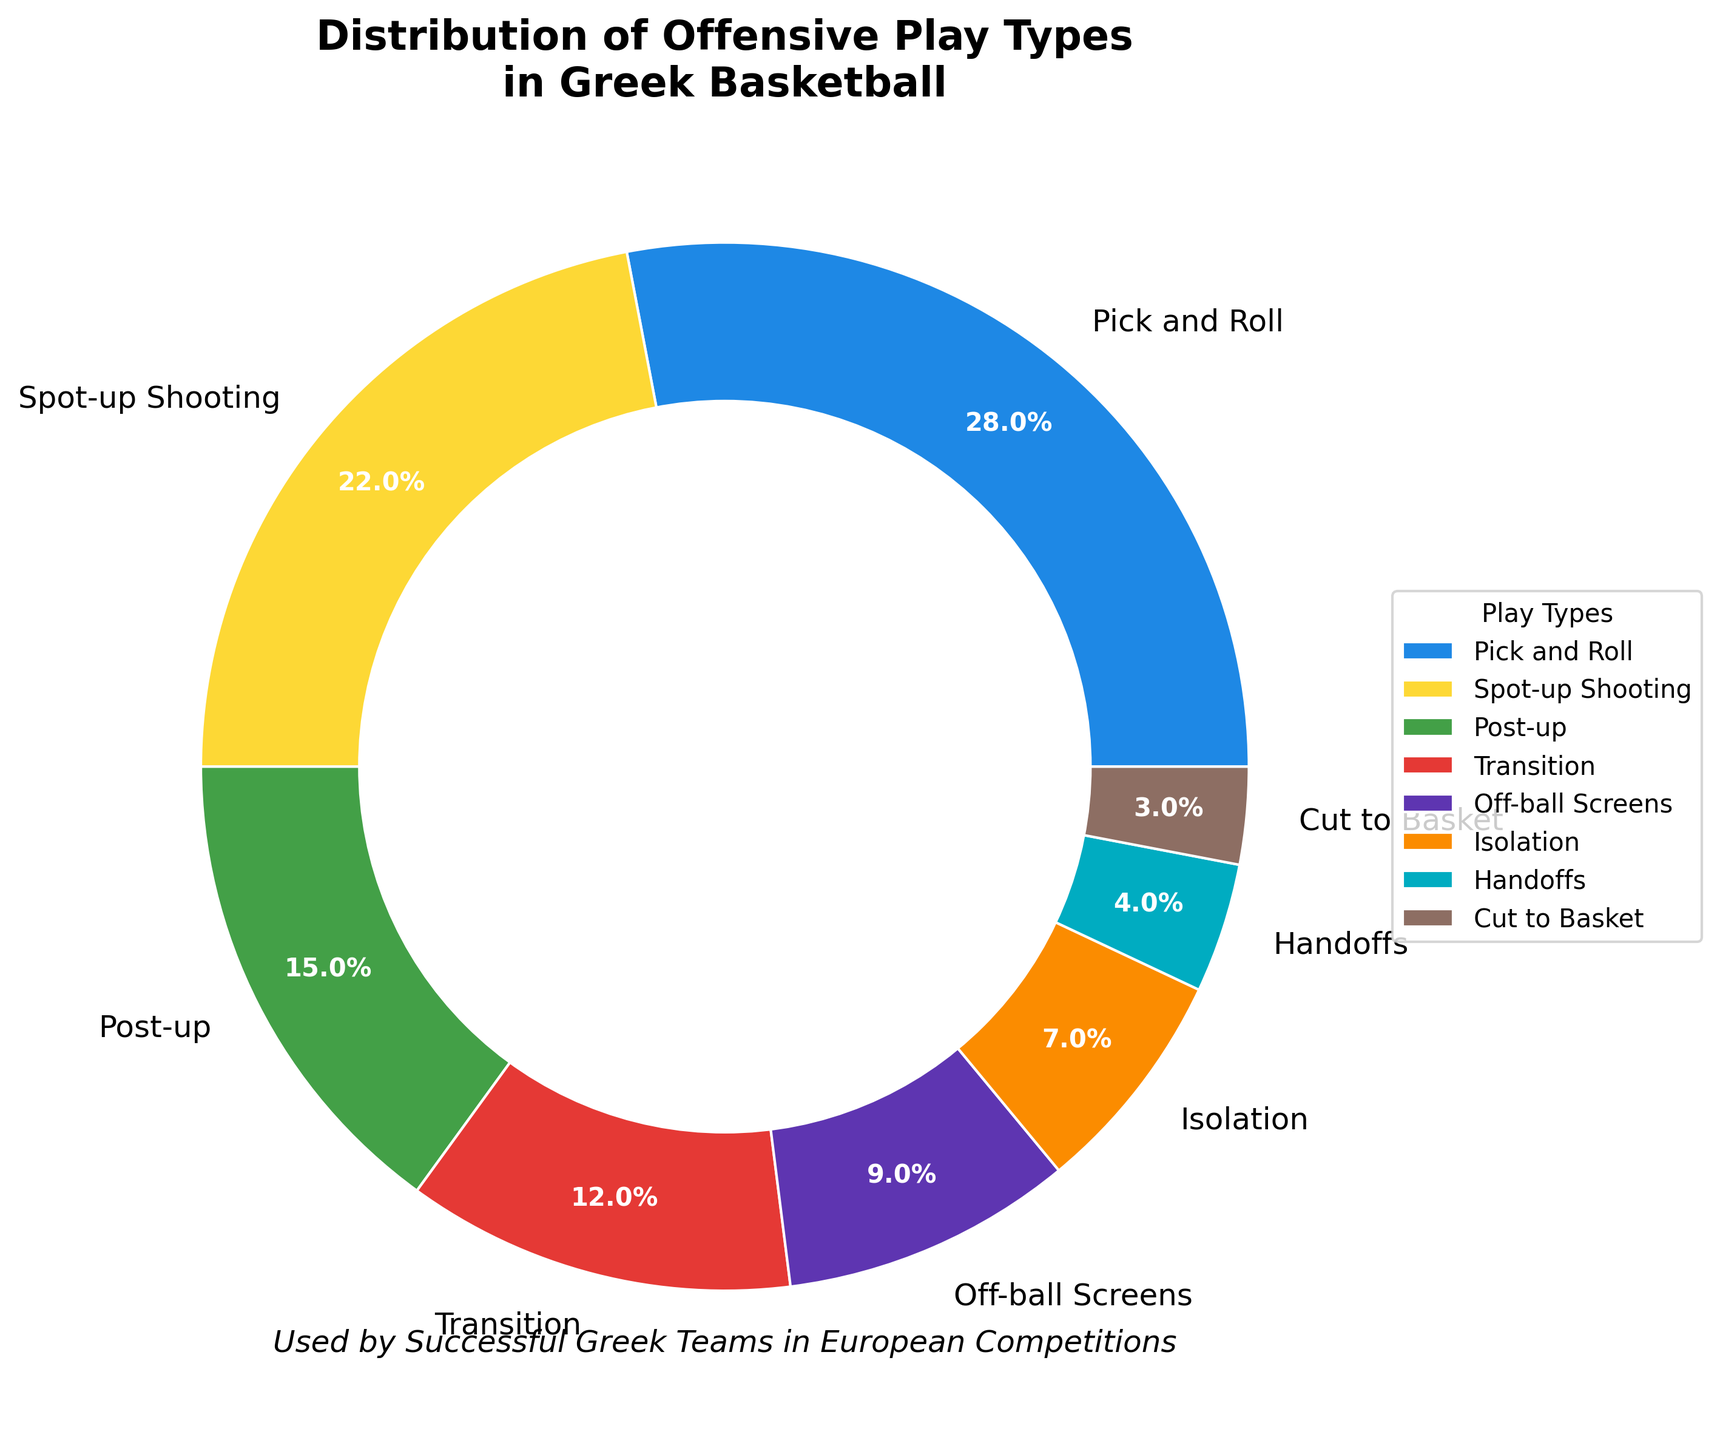What is the most commonly used offensive play type by successful Greek teams in European competitions? According to the pie chart, the play type with the highest percentage is Pick and Roll at 28%.
Answer: Pick and Roll How much more frequently is Spot-up Shooting used compared to Isolation? Spot-up Shooting has a percentage of 22%, whereas Isolation has 7%. The difference is 22 - 7 = 15%.
Answer: 15% Which play type is used more frequently, Transition or Off-ball Screens? The pie chart shows Transition at 12% and Off-ball Screens at 9%, so Transition is used more frequently.
Answer: Transition What percentage of offensive play types do Pick and Roll, Spot-up Shooting, and Post-up together account for? Adding the percentages of Pick and Roll (28%), Spot-up Shooting (22%), and Post-up (15%): 28 + 22 + 15 = 65%.
Answer: 65% Is the percentage of Handoffs greater than or less than the percentage of Cuts to Basket? Handoffs have a percentage of 4% and Cuts to Basket have 3%. Handoffs are greater.
Answer: Greater What is the least common offensive play type used by successful Greek teams? The pie chart shows that the least common offensive play type is Cut to Basket at 3%.
Answer: Cut to Basket How much more frequently are Pick and Roll and Transition plays used combined compared to Post-up and Handoffs combined? Adding Pick and Roll (28%) and Transition (12%), for a total of 40%. Adding Post-up (15%) and Handoffs (4%), for a total of 19%. The difference is 40 - 19 = 21%.
Answer: 21% Which play type is represented by the purple color in the pie chart? The purple color represents Post-up with 15%.
Answer: Post-up What is the total percentage of play types that have a percentage less than 10%? Adding the percentages of Off-ball Screens (9%), Isolation (7%), Handoffs (4%), and Cut to Basket (3%) results in 9 + 7 + 4 + 3 = 23%.
Answer: 23% 